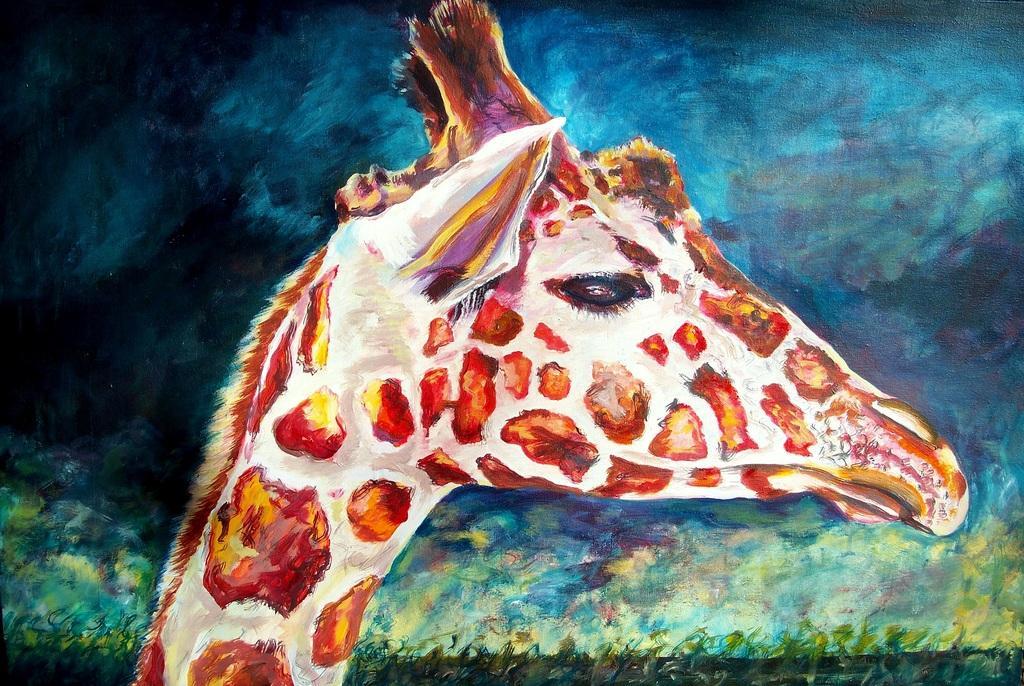How would you summarize this image in a sentence or two? There is a picture of a giraffe and the background is blue in color. 